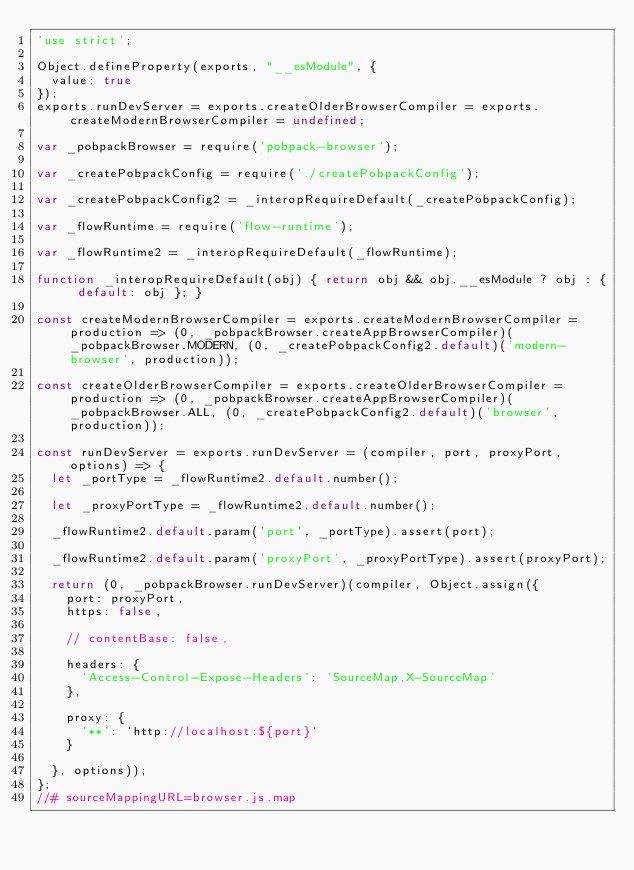Convert code to text. <code><loc_0><loc_0><loc_500><loc_500><_JavaScript_>'use strict';

Object.defineProperty(exports, "__esModule", {
  value: true
});
exports.runDevServer = exports.createOlderBrowserCompiler = exports.createModernBrowserCompiler = undefined;

var _pobpackBrowser = require('pobpack-browser');

var _createPobpackConfig = require('./createPobpackConfig');

var _createPobpackConfig2 = _interopRequireDefault(_createPobpackConfig);

var _flowRuntime = require('flow-runtime');

var _flowRuntime2 = _interopRequireDefault(_flowRuntime);

function _interopRequireDefault(obj) { return obj && obj.__esModule ? obj : { default: obj }; }

const createModernBrowserCompiler = exports.createModernBrowserCompiler = production => (0, _pobpackBrowser.createAppBrowserCompiler)(_pobpackBrowser.MODERN, (0, _createPobpackConfig2.default)('modern-browser', production));

const createOlderBrowserCompiler = exports.createOlderBrowserCompiler = production => (0, _pobpackBrowser.createAppBrowserCompiler)(_pobpackBrowser.ALL, (0, _createPobpackConfig2.default)('browser', production));

const runDevServer = exports.runDevServer = (compiler, port, proxyPort, options) => {
  let _portType = _flowRuntime2.default.number();

  let _proxyPortType = _flowRuntime2.default.number();

  _flowRuntime2.default.param('port', _portType).assert(port);

  _flowRuntime2.default.param('proxyPort', _proxyPortType).assert(proxyPort);

  return (0, _pobpackBrowser.runDevServer)(compiler, Object.assign({
    port: proxyPort,
    https: false,

    // contentBase: false,

    headers: {
      'Access-Control-Expose-Headers': 'SourceMap,X-SourceMap'
    },

    proxy: {
      '**': `http://localhost:${port}`
    }

  }, options));
};
//# sourceMappingURL=browser.js.map</code> 